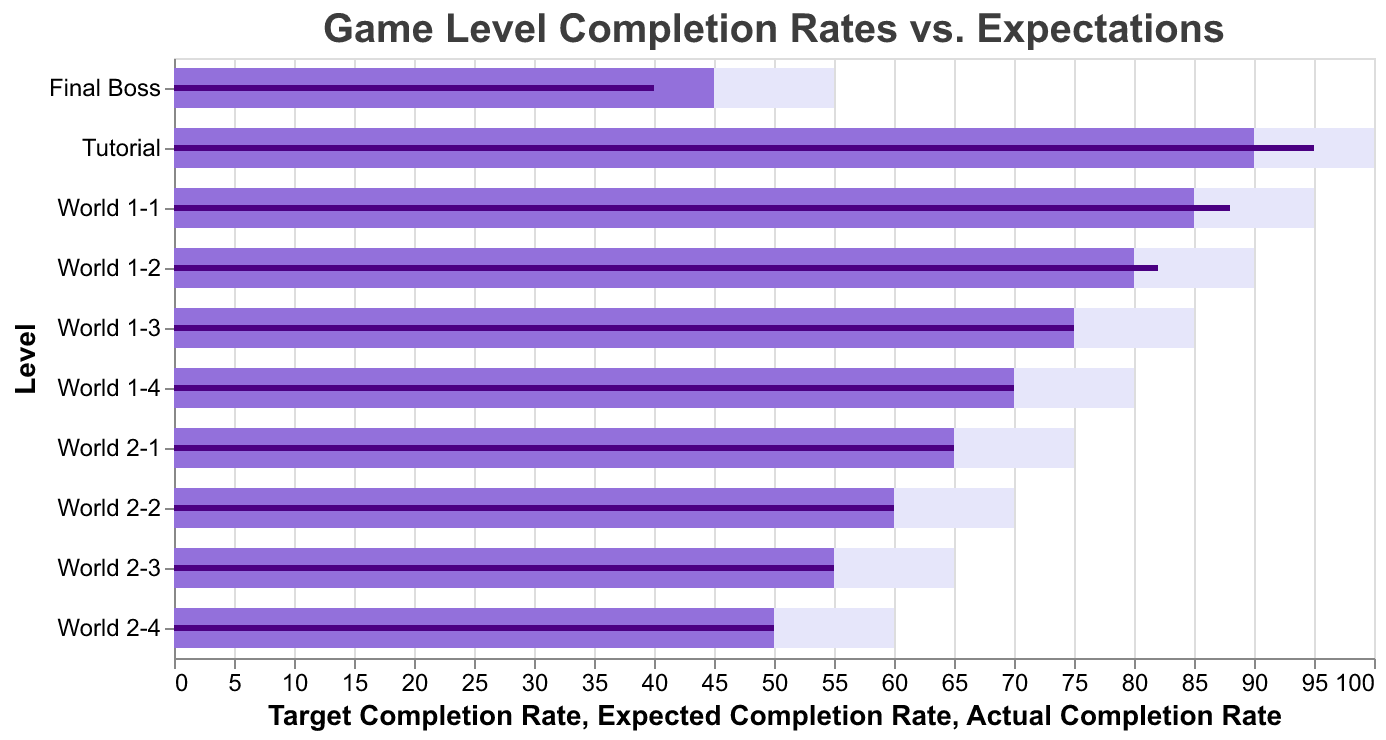What is the title of the figure? The title is prominently displayed at the top of the figure.
Answer: Game Level Completion Rates vs. Expectations How many levels are shown in the figure? Count the displayed levels on the y-axis or the data points.
Answer: 10 What is the color used to represent the actual completion rate? Look for the color corresponding to the "Actual Completion Rate" in the bars.
Answer: Dark purple What is the actual completion rate for World 1-3? Find the "World 1-3" row and locate the dark purple bar's value.
Answer: 75% By how much did the actual completion rate for the Final Boss fall short of the target completion rate? Subtract the actual completion rate from the target completion rate for the Final Boss level: 55 - 40.
Answer: 15% For which level was the actual completion rate exactly the same as the expected completion rate? Identify the levels where the value of "Actual Completion Rate" matches "Expected Completion Rate".
Answer: World 1-3, World 1-4, World 2-1, World 2-2, World 2-3, World 2-4 What is the average target completion rate across all levels? Sum up all target completion rates and divide by the number of levels: (100 + 95 + 90 + 85 + 80 + 75 + 70 + 65 + 60 + 55) / 10.
Answer: 77.5% Which level has the largest gap between actual completion rate and expected completion rate? Calculate the difference between actual and expected completion rates for each level, then determine the level with the maximum difference.
Answer: Final Boss Which level has the highest actual completion rate? Identify the level with the tallest dark purple bar or the maximum value in "Actual Completion Rate".
Answer: Tutorial How do the actual and expected completion rates of World 1-2 compare? Compare the lengths of the dark purple and medium purple bars for World 1-2.
Answer: Actual is slightly higher (82% vs. 80%) 